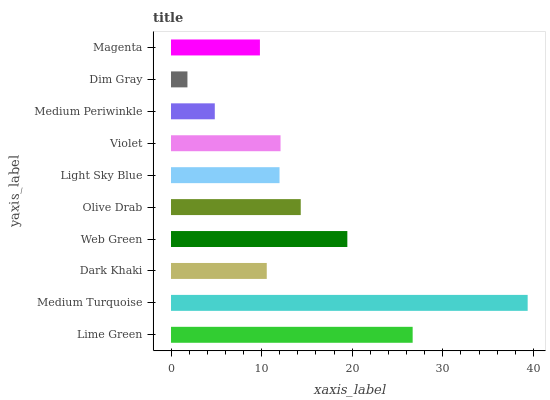Is Dim Gray the minimum?
Answer yes or no. Yes. Is Medium Turquoise the maximum?
Answer yes or no. Yes. Is Dark Khaki the minimum?
Answer yes or no. No. Is Dark Khaki the maximum?
Answer yes or no. No. Is Medium Turquoise greater than Dark Khaki?
Answer yes or no. Yes. Is Dark Khaki less than Medium Turquoise?
Answer yes or no. Yes. Is Dark Khaki greater than Medium Turquoise?
Answer yes or no. No. Is Medium Turquoise less than Dark Khaki?
Answer yes or no. No. Is Violet the high median?
Answer yes or no. Yes. Is Light Sky Blue the low median?
Answer yes or no. Yes. Is Medium Turquoise the high median?
Answer yes or no. No. Is Olive Drab the low median?
Answer yes or no. No. 